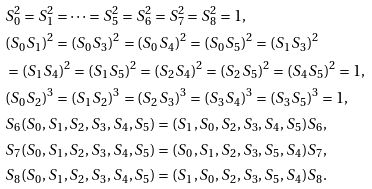Convert formula to latex. <formula><loc_0><loc_0><loc_500><loc_500>& S _ { 0 } ^ { 2 } = S _ { 1 } ^ { 2 } = \dots = S _ { 5 } ^ { 2 } = S _ { 6 } ^ { 2 } = S _ { 7 } ^ { 2 } = S _ { 8 } ^ { 2 } = 1 , \\ & ( S _ { 0 } S _ { 1 } ) ^ { 2 } = ( S _ { 0 } S _ { 3 } ) ^ { 2 } = ( S _ { 0 } S _ { 4 } ) ^ { 2 } = ( S _ { 0 } S _ { 5 } ) ^ { 2 } = ( S _ { 1 } S _ { 3 } ) ^ { 2 } \\ & = ( S _ { 1 } S _ { 4 } ) ^ { 2 } = ( S _ { 1 } S _ { 5 } ) ^ { 2 } = ( S _ { 2 } S _ { 4 } ) ^ { 2 } = ( S _ { 2 } S _ { 5 } ) ^ { 2 } = ( S _ { 4 } S _ { 5 } ) ^ { 2 } = 1 , \\ & ( S _ { 0 } S _ { 2 } ) ^ { 3 } = ( S _ { 1 } S _ { 2 } ) ^ { 3 } = ( S _ { 2 } S _ { 3 } ) ^ { 3 } = ( S _ { 3 } S _ { 4 } ) ^ { 3 } = ( S _ { 3 } S _ { 5 } ) ^ { 3 } = 1 , \\ & S _ { 6 } ( S _ { 0 } , S _ { 1 } , S _ { 2 } , S _ { 3 } , S _ { 4 } , S _ { 5 } ) = ( S _ { 1 } , S _ { 0 } , S _ { 2 } , S _ { 3 } , S _ { 4 } , S _ { 5 } ) S _ { 6 } , \\ & S _ { 7 } ( S _ { 0 } , S _ { 1 } , S _ { 2 } , S _ { 3 } , S _ { 4 } , S _ { 5 } ) = ( S _ { 0 } , S _ { 1 } , S _ { 2 } , S _ { 3 } , S _ { 5 } , S _ { 4 } ) S _ { 7 } , \\ & S _ { 8 } ( S _ { 0 } , S _ { 1 } , S _ { 2 } , S _ { 3 } , S _ { 4 } , S _ { 5 } ) = ( S _ { 1 } , S _ { 0 } , S _ { 2 } , S _ { 3 } , S _ { 5 } , S _ { 4 } ) S _ { 8 } .</formula> 